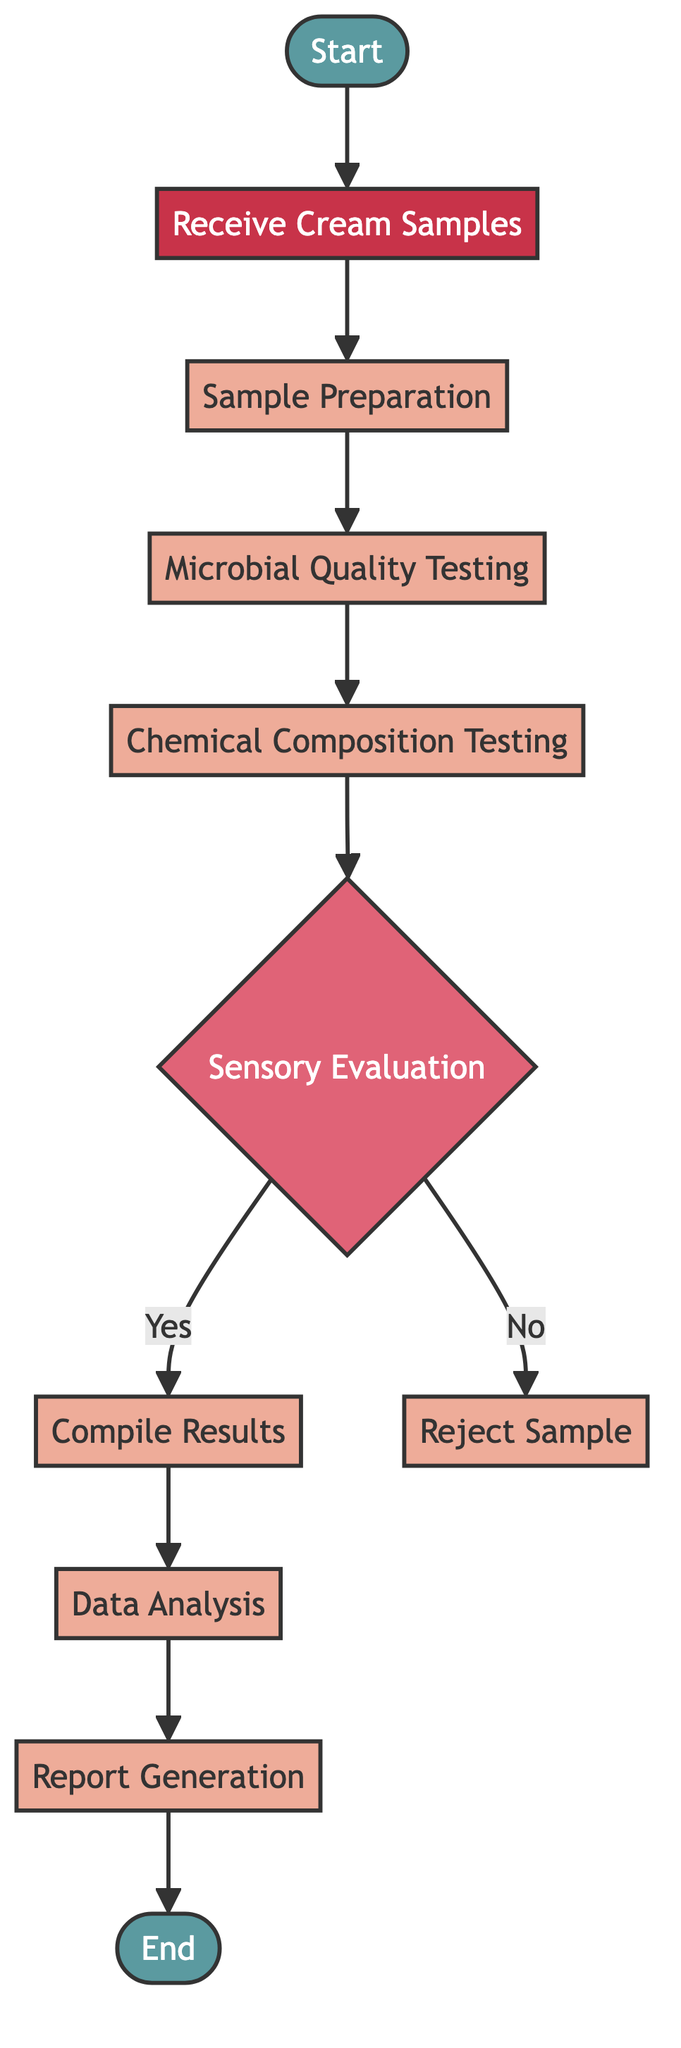What is the first step in the workflow? The first step in the workflow is denoted by the "Start" node, which indicates the beginning of the process.
Answer: Start How many processes are there in the workflow? By counting each node categorized as a process, we find "Sample Preparation," "Microbial Quality Testing," "Chemical Composition Testing," "Compile Results," "Data Analysis," and "Report Generation," which totals to six processes.
Answer: 6 What happens if the sensory evaluation is a no? If the sensory evaluation is a no, the workflow leads directly to the "Reject Sample" process, indicating that the sample does not meet the necessary standards.
Answer: Reject Sample Which process precedes the data analysis step? The "Compile Results" process directly proceeds the "Data Analysis" step in the workflow, as per the flowchart's direction.
Answer: Compile Results How do you reach the end of the workflow? To reach the end, the process moves sequentially through "Report Generation," which is the final process before "End" in the flowchart. Thus, traveling from "Report Generation" leads you directly to the "End."
Answer: End What is the purpose of the microbial quality testing process? The microbial quality testing process ensures safety and quality by evaluating the microbial content present in the cream samples, which is essential for consumer health.
Answer: Evaluate microbial content If the cream sample has good sensory evaluation, what are the subsequent steps? If the sensory evaluation is positive (yes), the workflow advances to compile the results, which then leads to data analysis and finally to report generation.
Answer: Compile Results How many decision points are in the flowchart? There is one decision point in the flowchart, which is the "Sensory Evaluation" node, as it decides whether to proceed with the sample or reject it.
Answer: 1 What node comes before the microbial quality testing? The node that comes before the microbial quality testing is "Sample Preparation," indicating that samples must be appropriately prepared before testing for microbial content.
Answer: Sample Preparation 